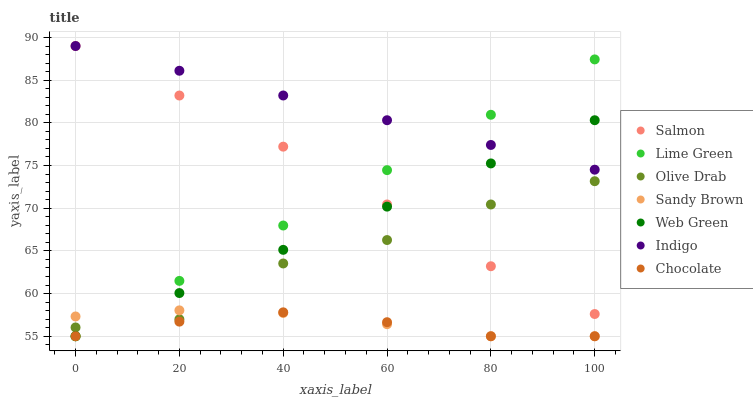Does Chocolate have the minimum area under the curve?
Answer yes or no. Yes. Does Indigo have the maximum area under the curve?
Answer yes or no. Yes. Does Sandy Brown have the minimum area under the curve?
Answer yes or no. No. Does Sandy Brown have the maximum area under the curve?
Answer yes or no. No. Is Lime Green the smoothest?
Answer yes or no. Yes. Is Olive Drab the roughest?
Answer yes or no. Yes. Is Sandy Brown the smoothest?
Answer yes or no. No. Is Sandy Brown the roughest?
Answer yes or no. No. Does Sandy Brown have the lowest value?
Answer yes or no. Yes. Does Salmon have the lowest value?
Answer yes or no. No. Does Salmon have the highest value?
Answer yes or no. Yes. Does Sandy Brown have the highest value?
Answer yes or no. No. Is Olive Drab less than Indigo?
Answer yes or no. Yes. Is Indigo greater than Sandy Brown?
Answer yes or no. Yes. Does Olive Drab intersect Web Green?
Answer yes or no. Yes. Is Olive Drab less than Web Green?
Answer yes or no. No. Is Olive Drab greater than Web Green?
Answer yes or no. No. Does Olive Drab intersect Indigo?
Answer yes or no. No. 